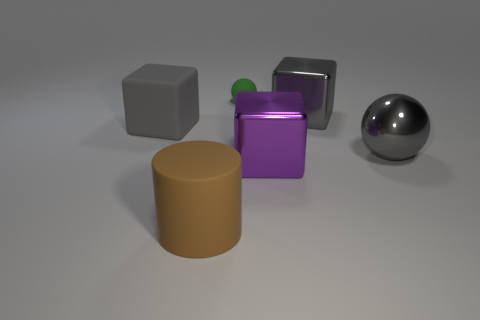There is a gray thing that is the same shape as the tiny green thing; what is its material?
Your response must be concise. Metal. What number of blue objects are either spheres or big matte cylinders?
Your answer should be compact. 0. Is there anything else that has the same color as the rubber cylinder?
Provide a short and direct response. No. The object behind the big shiny object behind the gray rubber block is what color?
Provide a short and direct response. Green. Are there fewer big matte cylinders right of the purple shiny object than green matte spheres that are in front of the tiny green object?
Ensure brevity in your answer.  No. What is the material of the other block that is the same color as the large matte cube?
Ensure brevity in your answer.  Metal. How many things are cubes behind the big metallic ball or cyan metallic things?
Give a very brief answer. 2. Do the object that is in front of the purple metal thing and the large rubber cube have the same size?
Ensure brevity in your answer.  Yes. Is the number of purple blocks in front of the cylinder less than the number of tiny yellow metallic cubes?
Keep it short and to the point. No. What is the material of the cylinder that is the same size as the purple block?
Your answer should be compact. Rubber. 